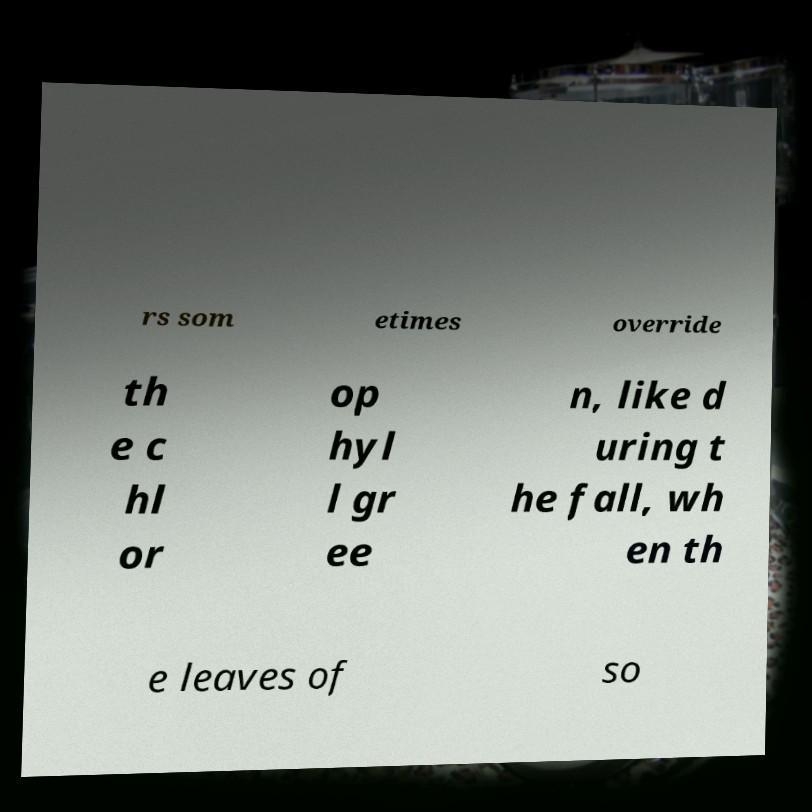What messages or text are displayed in this image? I need them in a readable, typed format. rs som etimes override th e c hl or op hyl l gr ee n, like d uring t he fall, wh en th e leaves of so 